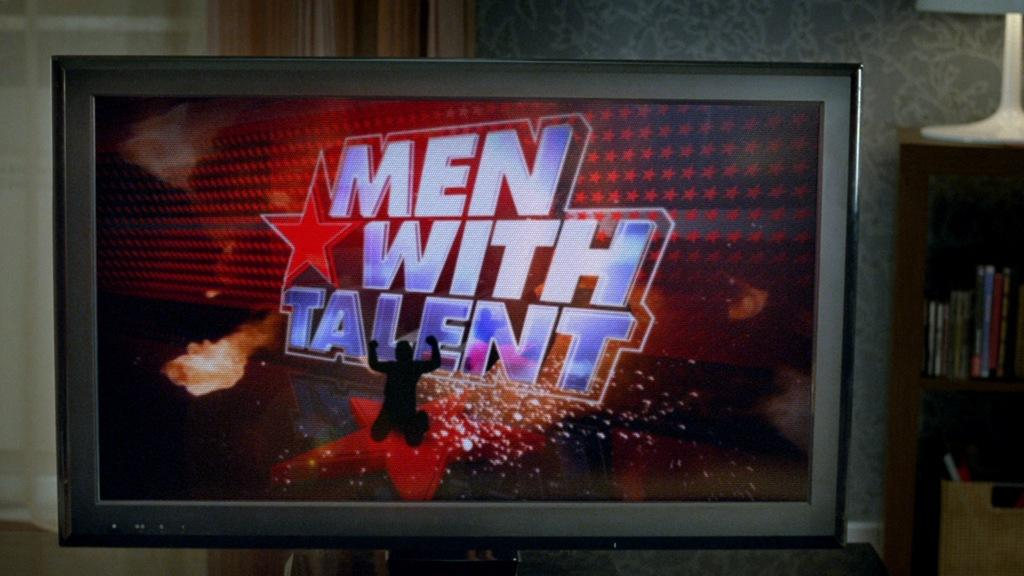<image>
Present a compact description of the photo's key features. The television screen shows the silhouette of a man on his knees and "Men with Talent" in big letters behind him. 